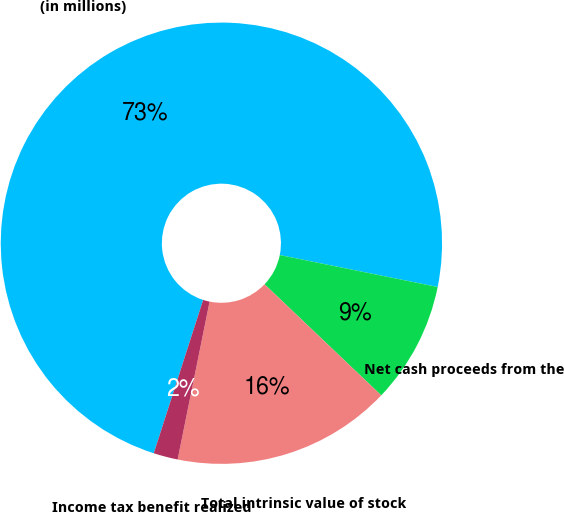Convert chart. <chart><loc_0><loc_0><loc_500><loc_500><pie_chart><fcel>(in millions)<fcel>Net cash proceeds from the<fcel>Total intrinsic value of stock<fcel>Income tax benefit realized<nl><fcel>73.22%<fcel>8.93%<fcel>16.07%<fcel>1.78%<nl></chart> 